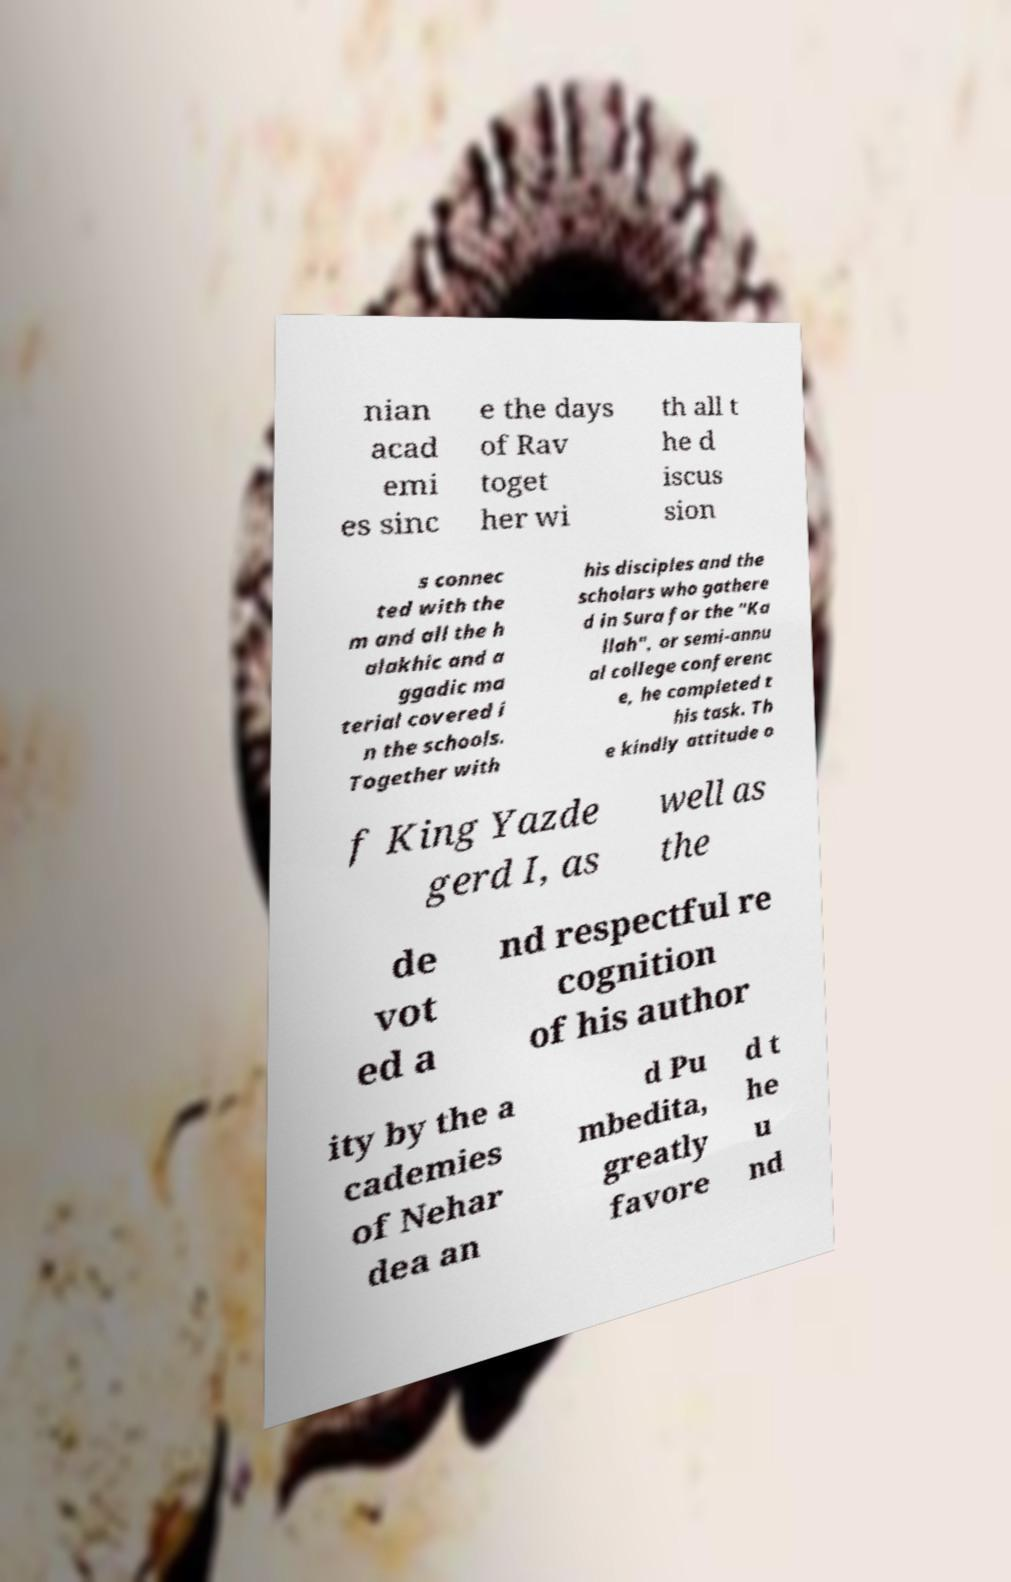For documentation purposes, I need the text within this image transcribed. Could you provide that? nian acad emi es sinc e the days of Rav toget her wi th all t he d iscus sion s connec ted with the m and all the h alakhic and a ggadic ma terial covered i n the schools. Together with his disciples and the scholars who gathere d in Sura for the "Ka llah", or semi-annu al college conferenc e, he completed t his task. Th e kindly attitude o f King Yazde gerd I, as well as the de vot ed a nd respectful re cognition of his author ity by the a cademies of Nehar dea an d Pu mbedita, greatly favore d t he u nd 